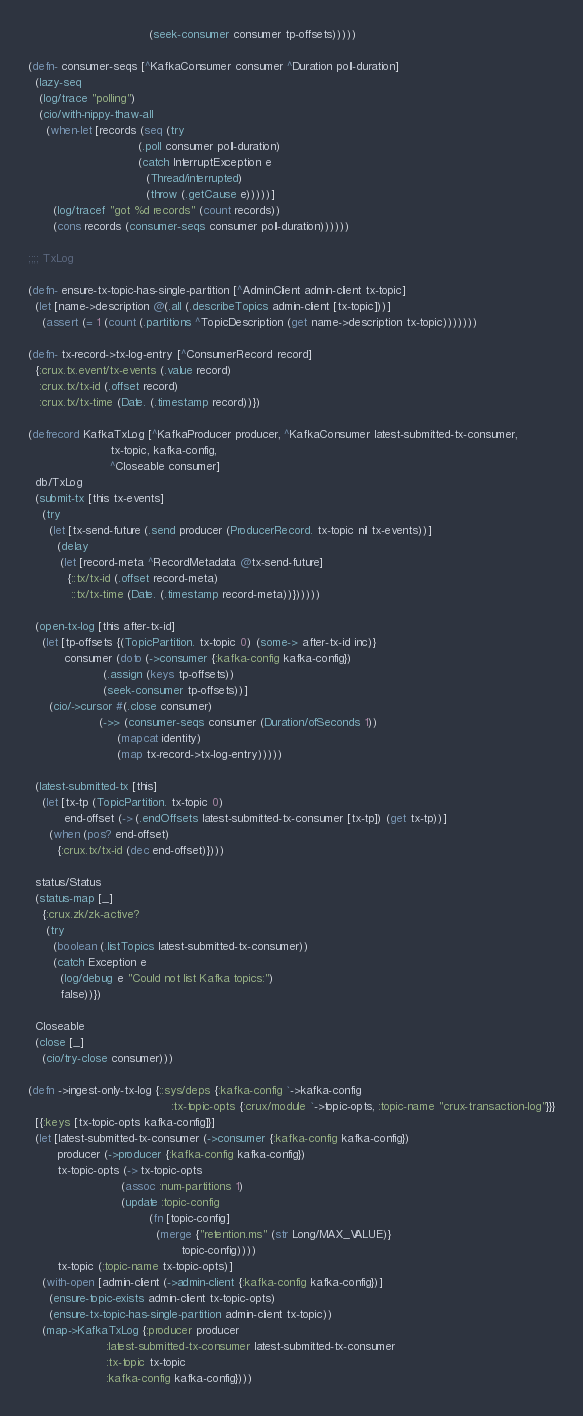Convert code to text. <code><loc_0><loc_0><loc_500><loc_500><_Clojure_>                                  (seek-consumer consumer tp-offsets)))))

(defn- consumer-seqs [^KafkaConsumer consumer ^Duration poll-duration]
  (lazy-seq
   (log/trace "polling")
   (cio/with-nippy-thaw-all
     (when-let [records (seq (try
                               (.poll consumer poll-duration)
                               (catch InterruptException e
                                 (Thread/interrupted)
                                 (throw (.getCause e)))))]
       (log/tracef "got %d records" (count records))
       (cons records (consumer-seqs consumer poll-duration))))))

;;;; TxLog

(defn- ensure-tx-topic-has-single-partition [^AdminClient admin-client tx-topic]
  (let [name->description @(.all (.describeTopics admin-client [tx-topic]))]
    (assert (= 1 (count (.partitions ^TopicDescription (get name->description tx-topic)))))))

(defn- tx-record->tx-log-entry [^ConsumerRecord record]
  {:crux.tx.event/tx-events (.value record)
   :crux.tx/tx-id (.offset record)
   :crux.tx/tx-time (Date. (.timestamp record))})

(defrecord KafkaTxLog [^KafkaProducer producer, ^KafkaConsumer latest-submitted-tx-consumer,
                       tx-topic, kafka-config,
                       ^Closeable consumer]
  db/TxLog
  (submit-tx [this tx-events]
    (try
      (let [tx-send-future (.send producer (ProducerRecord. tx-topic nil tx-events))]
        (delay
         (let [record-meta ^RecordMetadata @tx-send-future]
           {::tx/tx-id (.offset record-meta)
            ::tx/tx-time (Date. (.timestamp record-meta))})))))

  (open-tx-log [this after-tx-id]
    (let [tp-offsets {(TopicPartition. tx-topic 0) (some-> after-tx-id inc)}
          consumer (doto (->consumer {:kafka-config kafka-config})
                     (.assign (keys tp-offsets))
                     (seek-consumer tp-offsets))]
      (cio/->cursor #(.close consumer)
                    (->> (consumer-seqs consumer (Duration/ofSeconds 1))
                         (mapcat identity)
                         (map tx-record->tx-log-entry)))))

  (latest-submitted-tx [this]
    (let [tx-tp (TopicPartition. tx-topic 0)
          end-offset (-> (.endOffsets latest-submitted-tx-consumer [tx-tp]) (get tx-tp))]
      (when (pos? end-offset)
        {:crux.tx/tx-id (dec end-offset)})))

  status/Status
  (status-map [_]
    {:crux.zk/zk-active?
     (try
       (boolean (.listTopics latest-submitted-tx-consumer))
       (catch Exception e
         (log/debug e "Could not list Kafka topics:")
         false))})

  Closeable
  (close [_]
    (cio/try-close consumer)))

(defn ->ingest-only-tx-log {::sys/deps {:kafka-config `->kafka-config
                                        :tx-topic-opts {:crux/module `->topic-opts, :topic-name "crux-transaction-log"}}}
  [{:keys [tx-topic-opts kafka-config]}]
  (let [latest-submitted-tx-consumer (->consumer {:kafka-config kafka-config})
        producer (->producer {:kafka-config kafka-config})
        tx-topic-opts (-> tx-topic-opts
                          (assoc :num-partitions 1)
                          (update :topic-config
                                  (fn [topic-config]
                                    (merge {"retention.ms" (str Long/MAX_VALUE)}
                                           topic-config))))
        tx-topic (:topic-name tx-topic-opts)]
    (with-open [admin-client (->admin-client {:kafka-config kafka-config})]
      (ensure-topic-exists admin-client tx-topic-opts)
      (ensure-tx-topic-has-single-partition admin-client tx-topic))
    (map->KafkaTxLog {:producer producer
                      :latest-submitted-tx-consumer latest-submitted-tx-consumer
                      :tx-topic tx-topic
                      :kafka-config kafka-config})))
</code> 